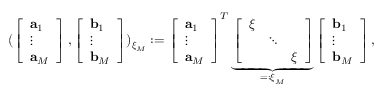<formula> <loc_0><loc_0><loc_500><loc_500>( \left [ \begin{array} { l } { a _ { 1 } } \\ { \vdots } \\ { a _ { M } } \end{array} \right ] , \left [ \begin{array} { l } { b _ { 1 } } \\ { \vdots } \\ { b _ { M } } \end{array} \right ] ) _ { \xi _ { M } } \colon = \left [ \begin{array} { l } { a _ { 1 } } \\ { \vdots } \\ { a _ { M } } \end{array} \right ] ^ { T } \underbrace { \left [ \begin{array} { l l l } { \xi } & & \\ & { \ddots } & \\ & & { \xi } \end{array} \right ] } _ { = \colon \xi _ { M } } \left [ \begin{array} { l } { b _ { 1 } } \\ { \vdots } \\ { b _ { M } } \end{array} \right ] ,</formula> 